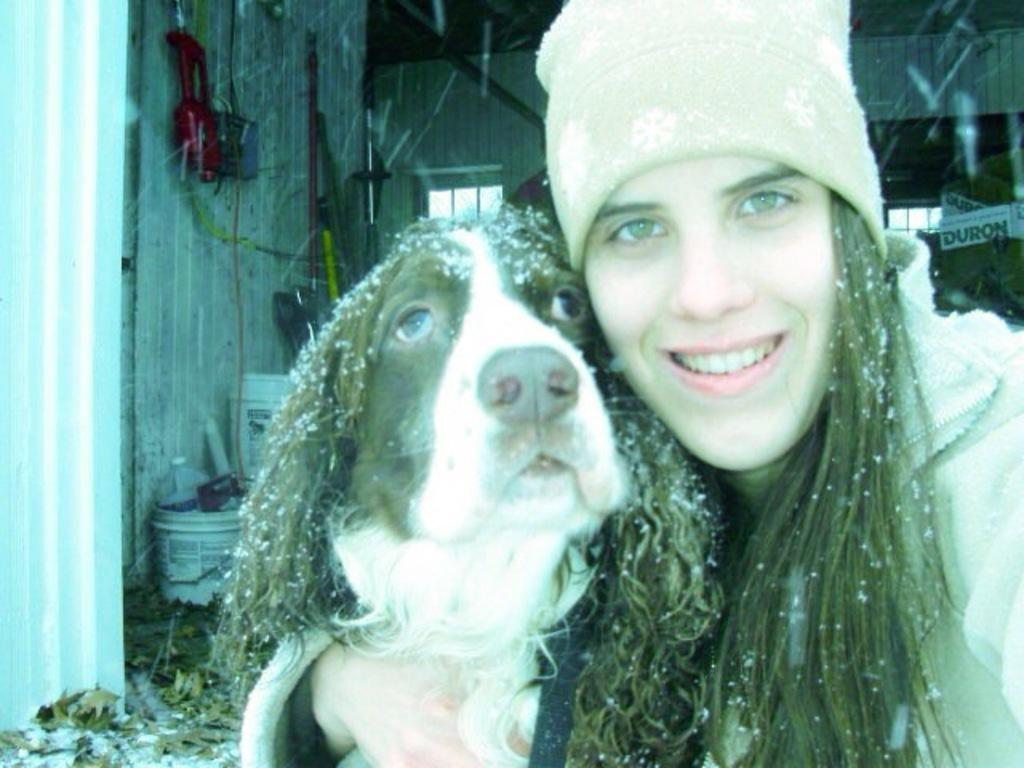What is the main subject of the image? The main subject of the image is a woman. What is the woman wearing on her head? The woman is wearing a cap. What is the woman holding in the image? The woman is holding a dog with her hands. What is the woman's facial expression? The woman is smiling. What can be seen in the background of the image? In the background of the image, there is a wall, a window, buckets, a can, boxes, poles, and leaves. What type of quill is the woman using to write on the wall in the image? There is no quill present in the image, and the woman is not writing on the wall. What kind of cream is being applied to the dog's fur in the image? There is no cream being applied to the dog's fur in the image. Is there a maid in the image assisting the woman with the dog? There is no maid present in the image. 